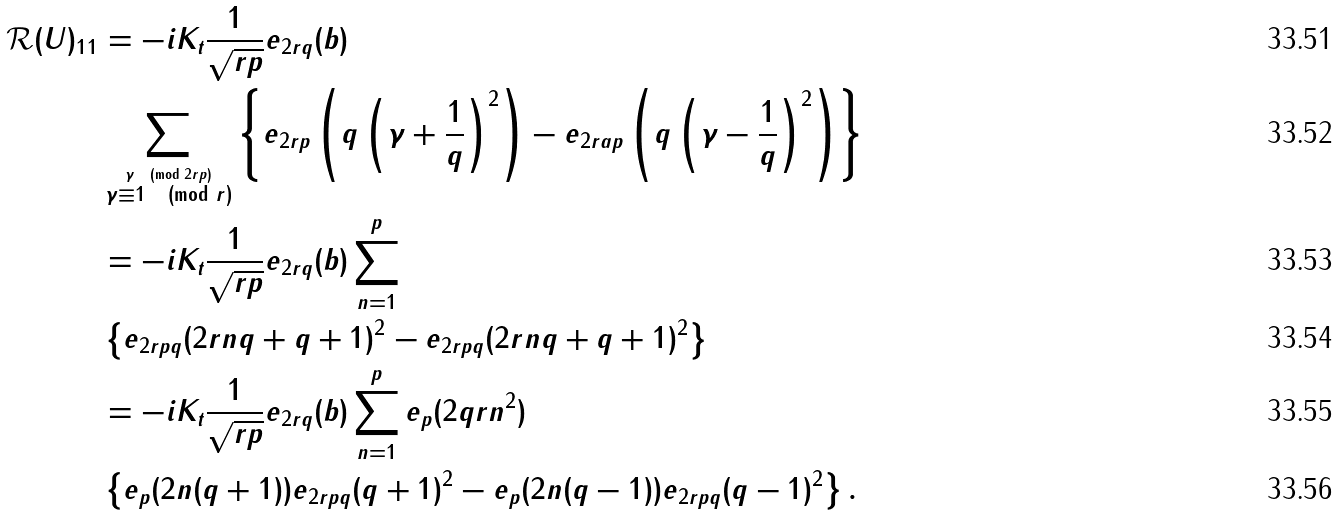<formula> <loc_0><loc_0><loc_500><loc_500>\mathcal { R } ( U ) _ { 1 1 } & = - i K _ { t } \frac { 1 } { \sqrt { r p } } e _ { 2 r q } ( b ) \\ & \sum _ { \stackrel { \gamma \pmod { 2 r p } } { \gamma \equiv 1 \pmod { r } } } \left \{ e _ { 2 r p } \left ( q \left ( \gamma + \frac { 1 } { q } \right ) ^ { 2 } \right ) - e _ { 2 r a p } \left ( q \left ( \gamma - \frac { 1 } { q } \right ) ^ { 2 } \right ) \right \} \\ & = - i K _ { t } \frac { 1 } { \sqrt { r p } } e _ { 2 r q } ( b ) \sum _ { n = 1 } ^ { p } \\ & \left \{ e _ { 2 r p q } ( 2 r n q + q + 1 ) ^ { 2 } - e _ { 2 r p q } ( 2 r n q + q + 1 ) ^ { 2 } \right \} \\ & = - i K _ { t } \frac { 1 } { \sqrt { r p } } e _ { 2 r q } ( b ) \sum _ { n = 1 } ^ { p } e _ { p } ( 2 q r n ^ { 2 } ) \\ & \left \{ e _ { p } ( 2 n ( q + 1 ) ) e _ { 2 r p q } ( q + 1 ) ^ { 2 } - e _ { p } ( 2 n ( q - 1 ) ) e _ { 2 r p q } ( q - 1 ) ^ { 2 } \right \} .</formula> 